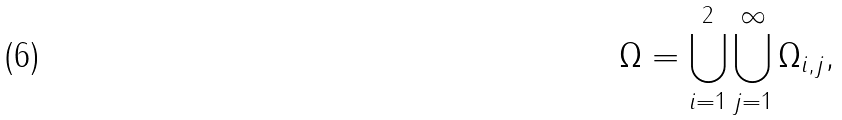Convert formula to latex. <formula><loc_0><loc_0><loc_500><loc_500>\Omega = \bigcup _ { i = 1 } ^ { 2 } \bigcup _ { j = 1 } ^ { \infty } \Omega _ { i , j } ,</formula> 